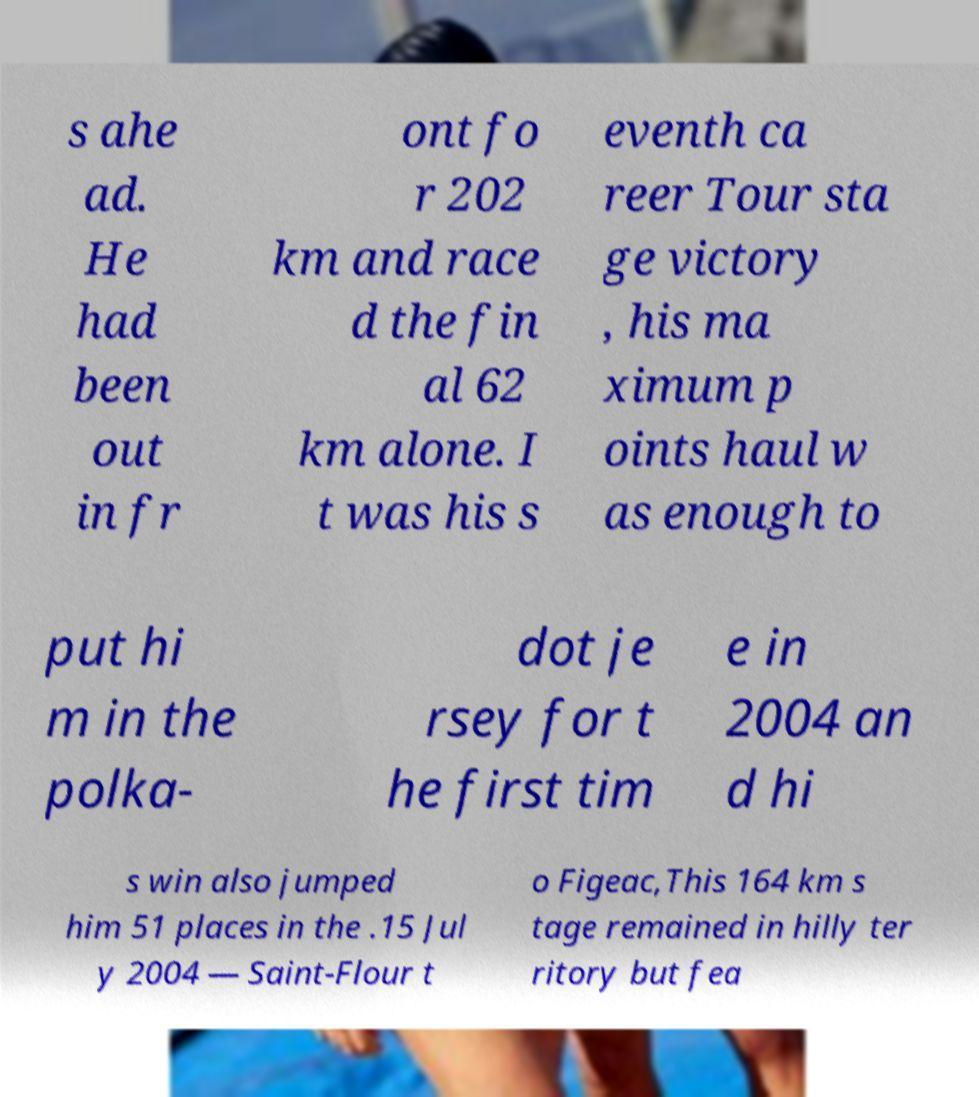Please identify and transcribe the text found in this image. s ahe ad. He had been out in fr ont fo r 202 km and race d the fin al 62 km alone. I t was his s eventh ca reer Tour sta ge victory , his ma ximum p oints haul w as enough to put hi m in the polka- dot je rsey for t he first tim e in 2004 an d hi s win also jumped him 51 places in the .15 Jul y 2004 — Saint-Flour t o Figeac,This 164 km s tage remained in hilly ter ritory but fea 